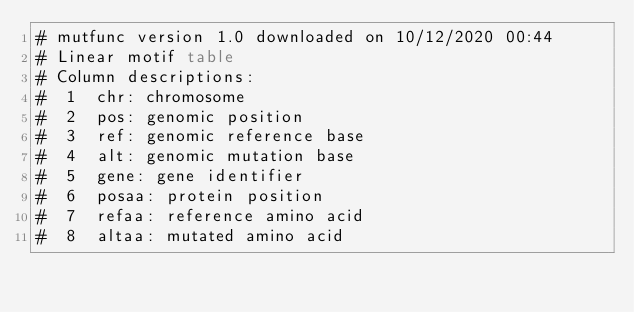<code> <loc_0><loc_0><loc_500><loc_500><_SQL_># mutfunc version 1.0 downloaded on 10/12/2020 00:44
# Linear motif table
# Column descriptions: 
#  1  chr: chromosome
#  2  pos: genomic position
#  3  ref: genomic reference base
#  4  alt: genomic mutation base
#  5  gene: gene identifier
#  6  posaa: protein position
#  7  refaa: reference amino acid
#  8  altaa: mutated amino acid</code> 